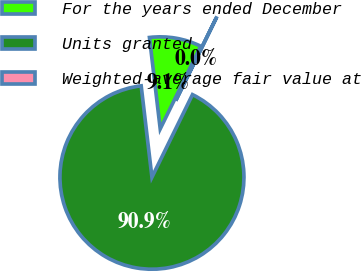Convert chart to OTSL. <chart><loc_0><loc_0><loc_500><loc_500><pie_chart><fcel>For the years ended December<fcel>Units granted<fcel>Weighted-average fair value at<nl><fcel>9.11%<fcel>90.87%<fcel>0.02%<nl></chart> 